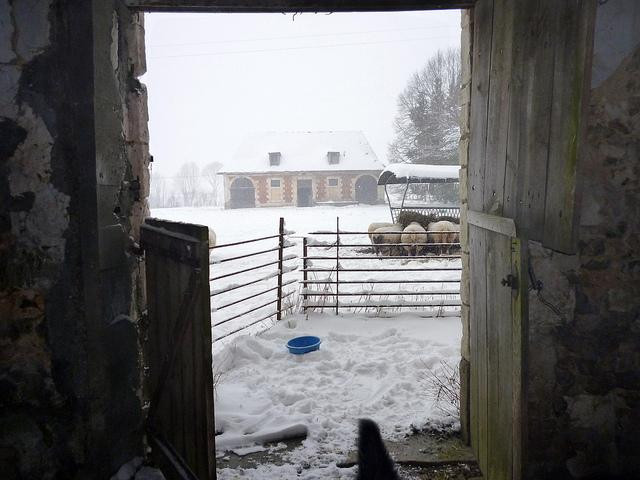From what kind of building was this picture taken?

Choices:
A) silo
B) barn
C) house
D) trailer barn 